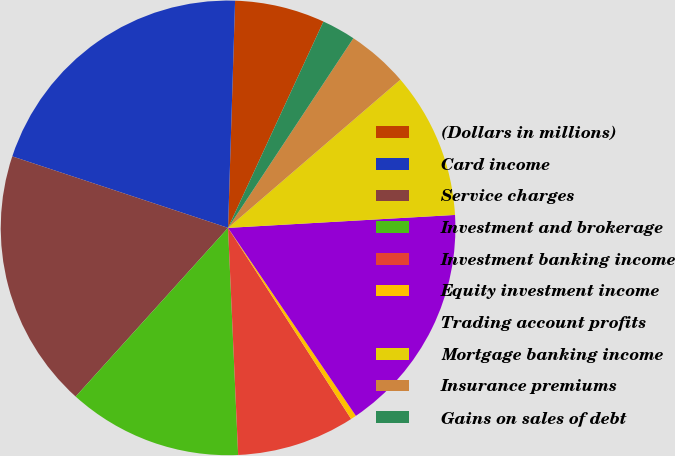Convert chart to OTSL. <chart><loc_0><loc_0><loc_500><loc_500><pie_chart><fcel>(Dollars in millions)<fcel>Card income<fcel>Service charges<fcel>Investment and brokerage<fcel>Investment banking income<fcel>Equity investment income<fcel>Trading account profits<fcel>Mortgage banking income<fcel>Insurance premiums<fcel>Gains on sales of debt<nl><fcel>6.4%<fcel>20.4%<fcel>18.4%<fcel>12.4%<fcel>8.4%<fcel>0.4%<fcel>16.4%<fcel>10.4%<fcel>4.4%<fcel>2.4%<nl></chart> 